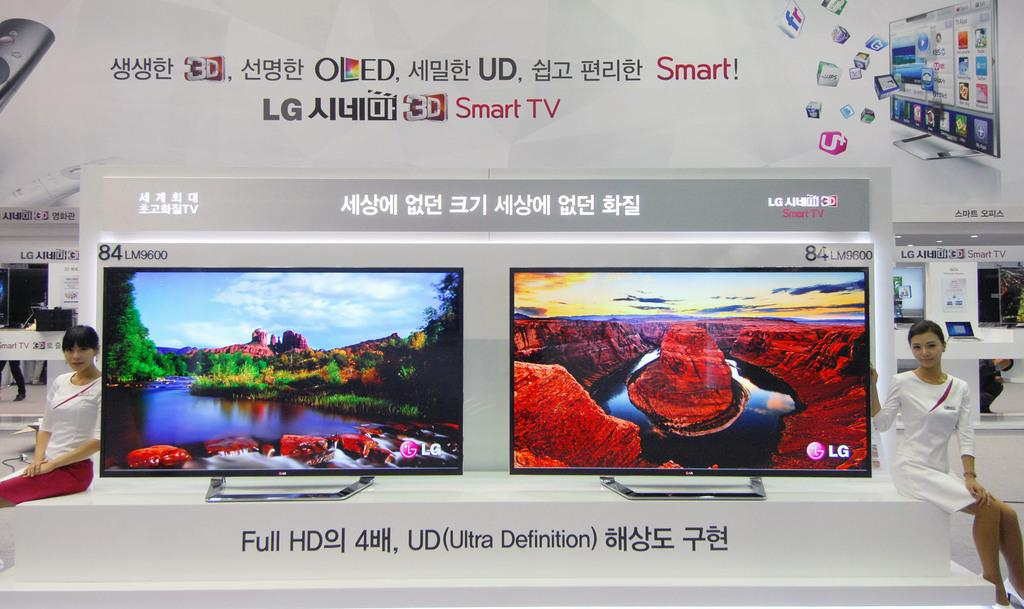<image>
Give a short and clear explanation of the subsequent image. Woman posing in front of television that has the brand LG on it. 